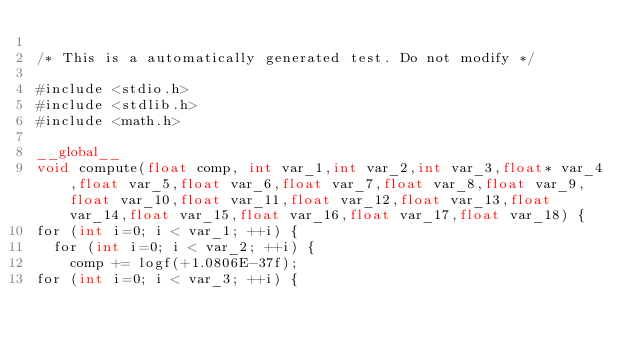<code> <loc_0><loc_0><loc_500><loc_500><_Cuda_>
/* This is a automatically generated test. Do not modify */

#include <stdio.h>
#include <stdlib.h>
#include <math.h>

__global__
void compute(float comp, int var_1,int var_2,int var_3,float* var_4,float var_5,float var_6,float var_7,float var_8,float var_9,float var_10,float var_11,float var_12,float var_13,float var_14,float var_15,float var_16,float var_17,float var_18) {
for (int i=0; i < var_1; ++i) {
  for (int i=0; i < var_2; ++i) {
    comp += logf(+1.0806E-37f);
for (int i=0; i < var_3; ++i) {</code> 